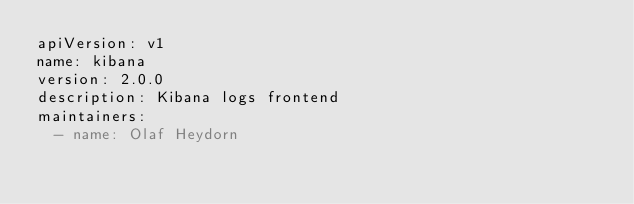Convert code to text. <code><loc_0><loc_0><loc_500><loc_500><_YAML_>apiVersion: v1
name: kibana
version: 2.0.0
description: Kibana logs frontend
maintainers:
  - name: Olaf Heydorn
</code> 